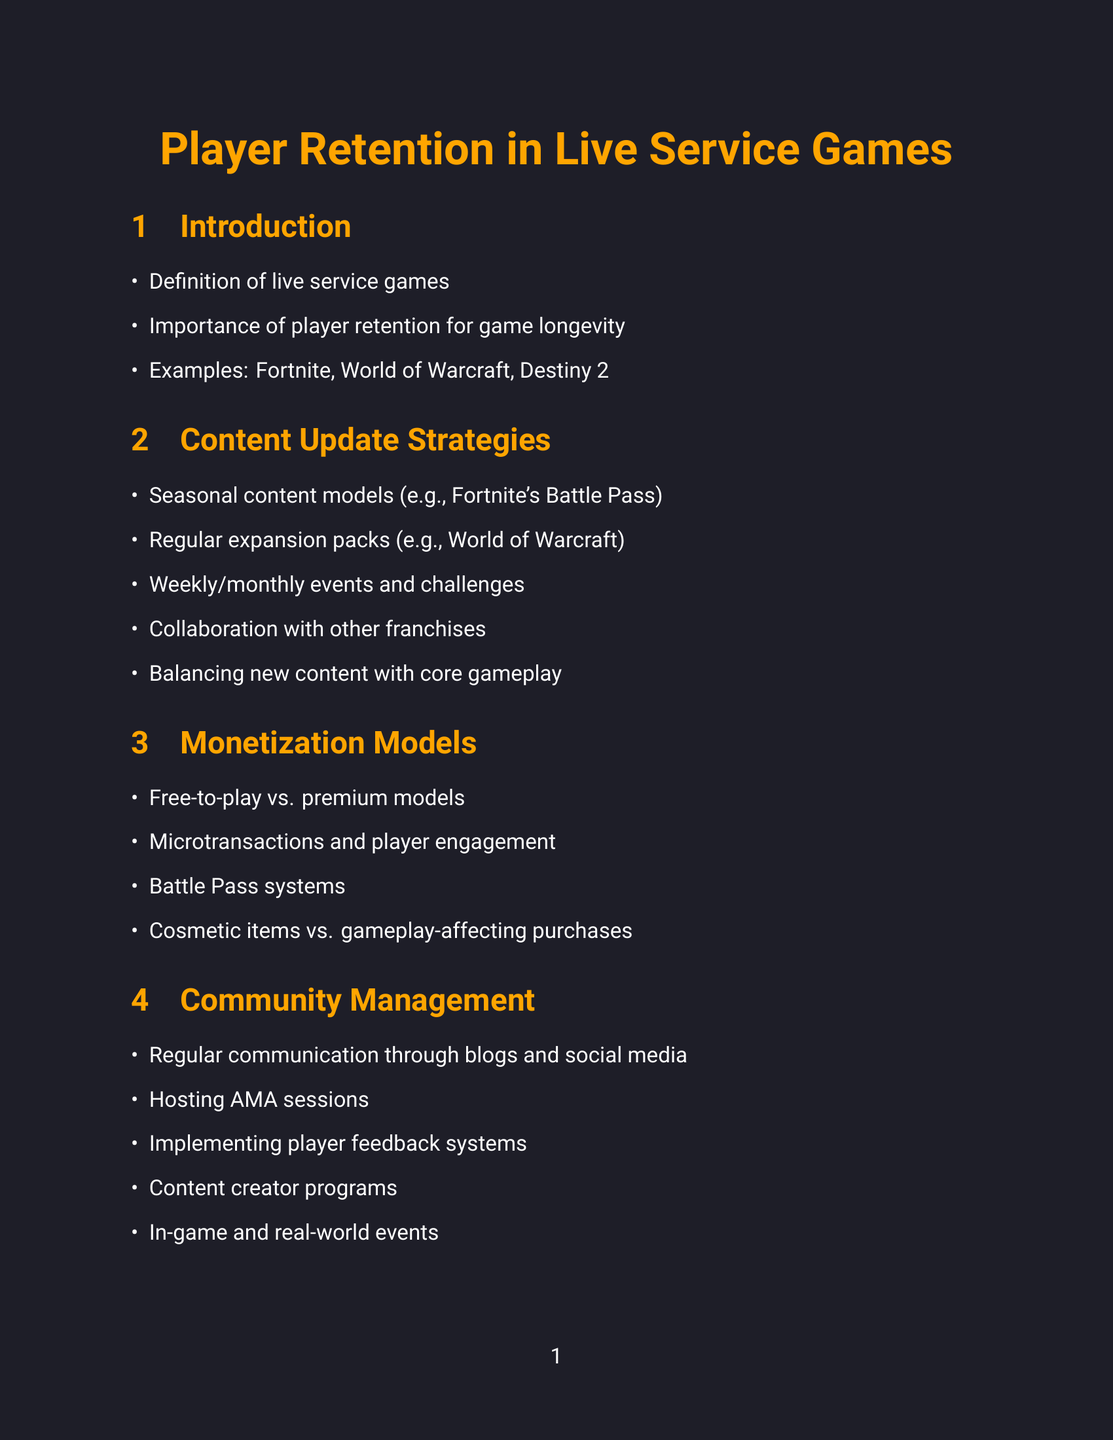What are live service games? Live service games are defined within the introduction section of the report as a category of games that are continually updated and managed to retain player interest.
Answer: Definition of live service games Which game is mentioned as an example of a successful live service game? The introduction section lists examples of successful live service games, which includes Fortnite, World of Warcraft, and Destiny 2.
Answer: Fortnite What is a seasonal content model? The content update strategies section defines this as a system exemplified by Fortnite's Battle Pass system, which includes timed progression and rewards.
Answer: Fortnite's Battle Pass system How many years has World of Warcraft maintained its player base? In the case studies section, it states that World of Warcraft has maintained its player base for over 15 years.
Answer: Over 15 years What is one community management best practice mentioned? The community management section mentions several practices, including regular communication through developer blogs and social media, highlighting the importance of staying connected with players.
Answer: Regular communication through developer blogs and social media Which tools are used for community management? The tools and platforms section outlines Discord as a platform specifically utilized for community management and direct communication with players.
Answer: Discord What does the future trend section suggest about personalized content? It discusses the integration of AI for generating personalized content as a future trend in player retention strategies.
Answer: AI for personalized content generation What should developers identify when crafting a retention strategy? The conclusion section advises that developers should identify their target audience and understand their preferences as an essential step in crafting a retention strategy.
Answer: Identifying target audience and their preferences 